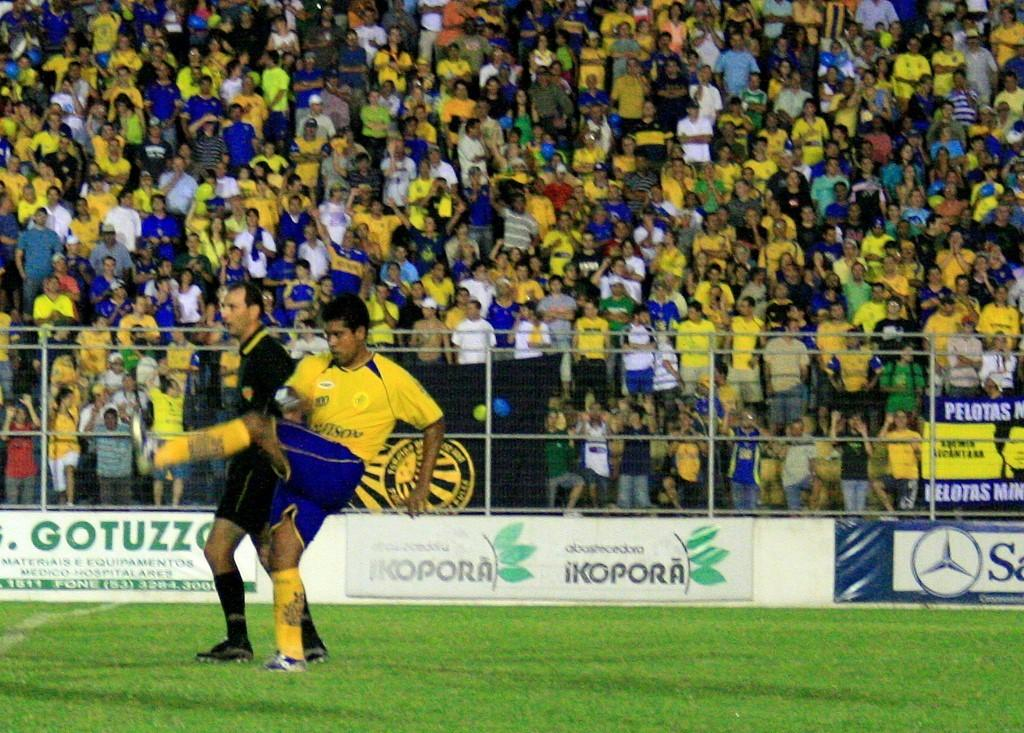<image>
Create a compact narrative representing the image presented. A soccer player from a team named Pelotas finishing his kick. 